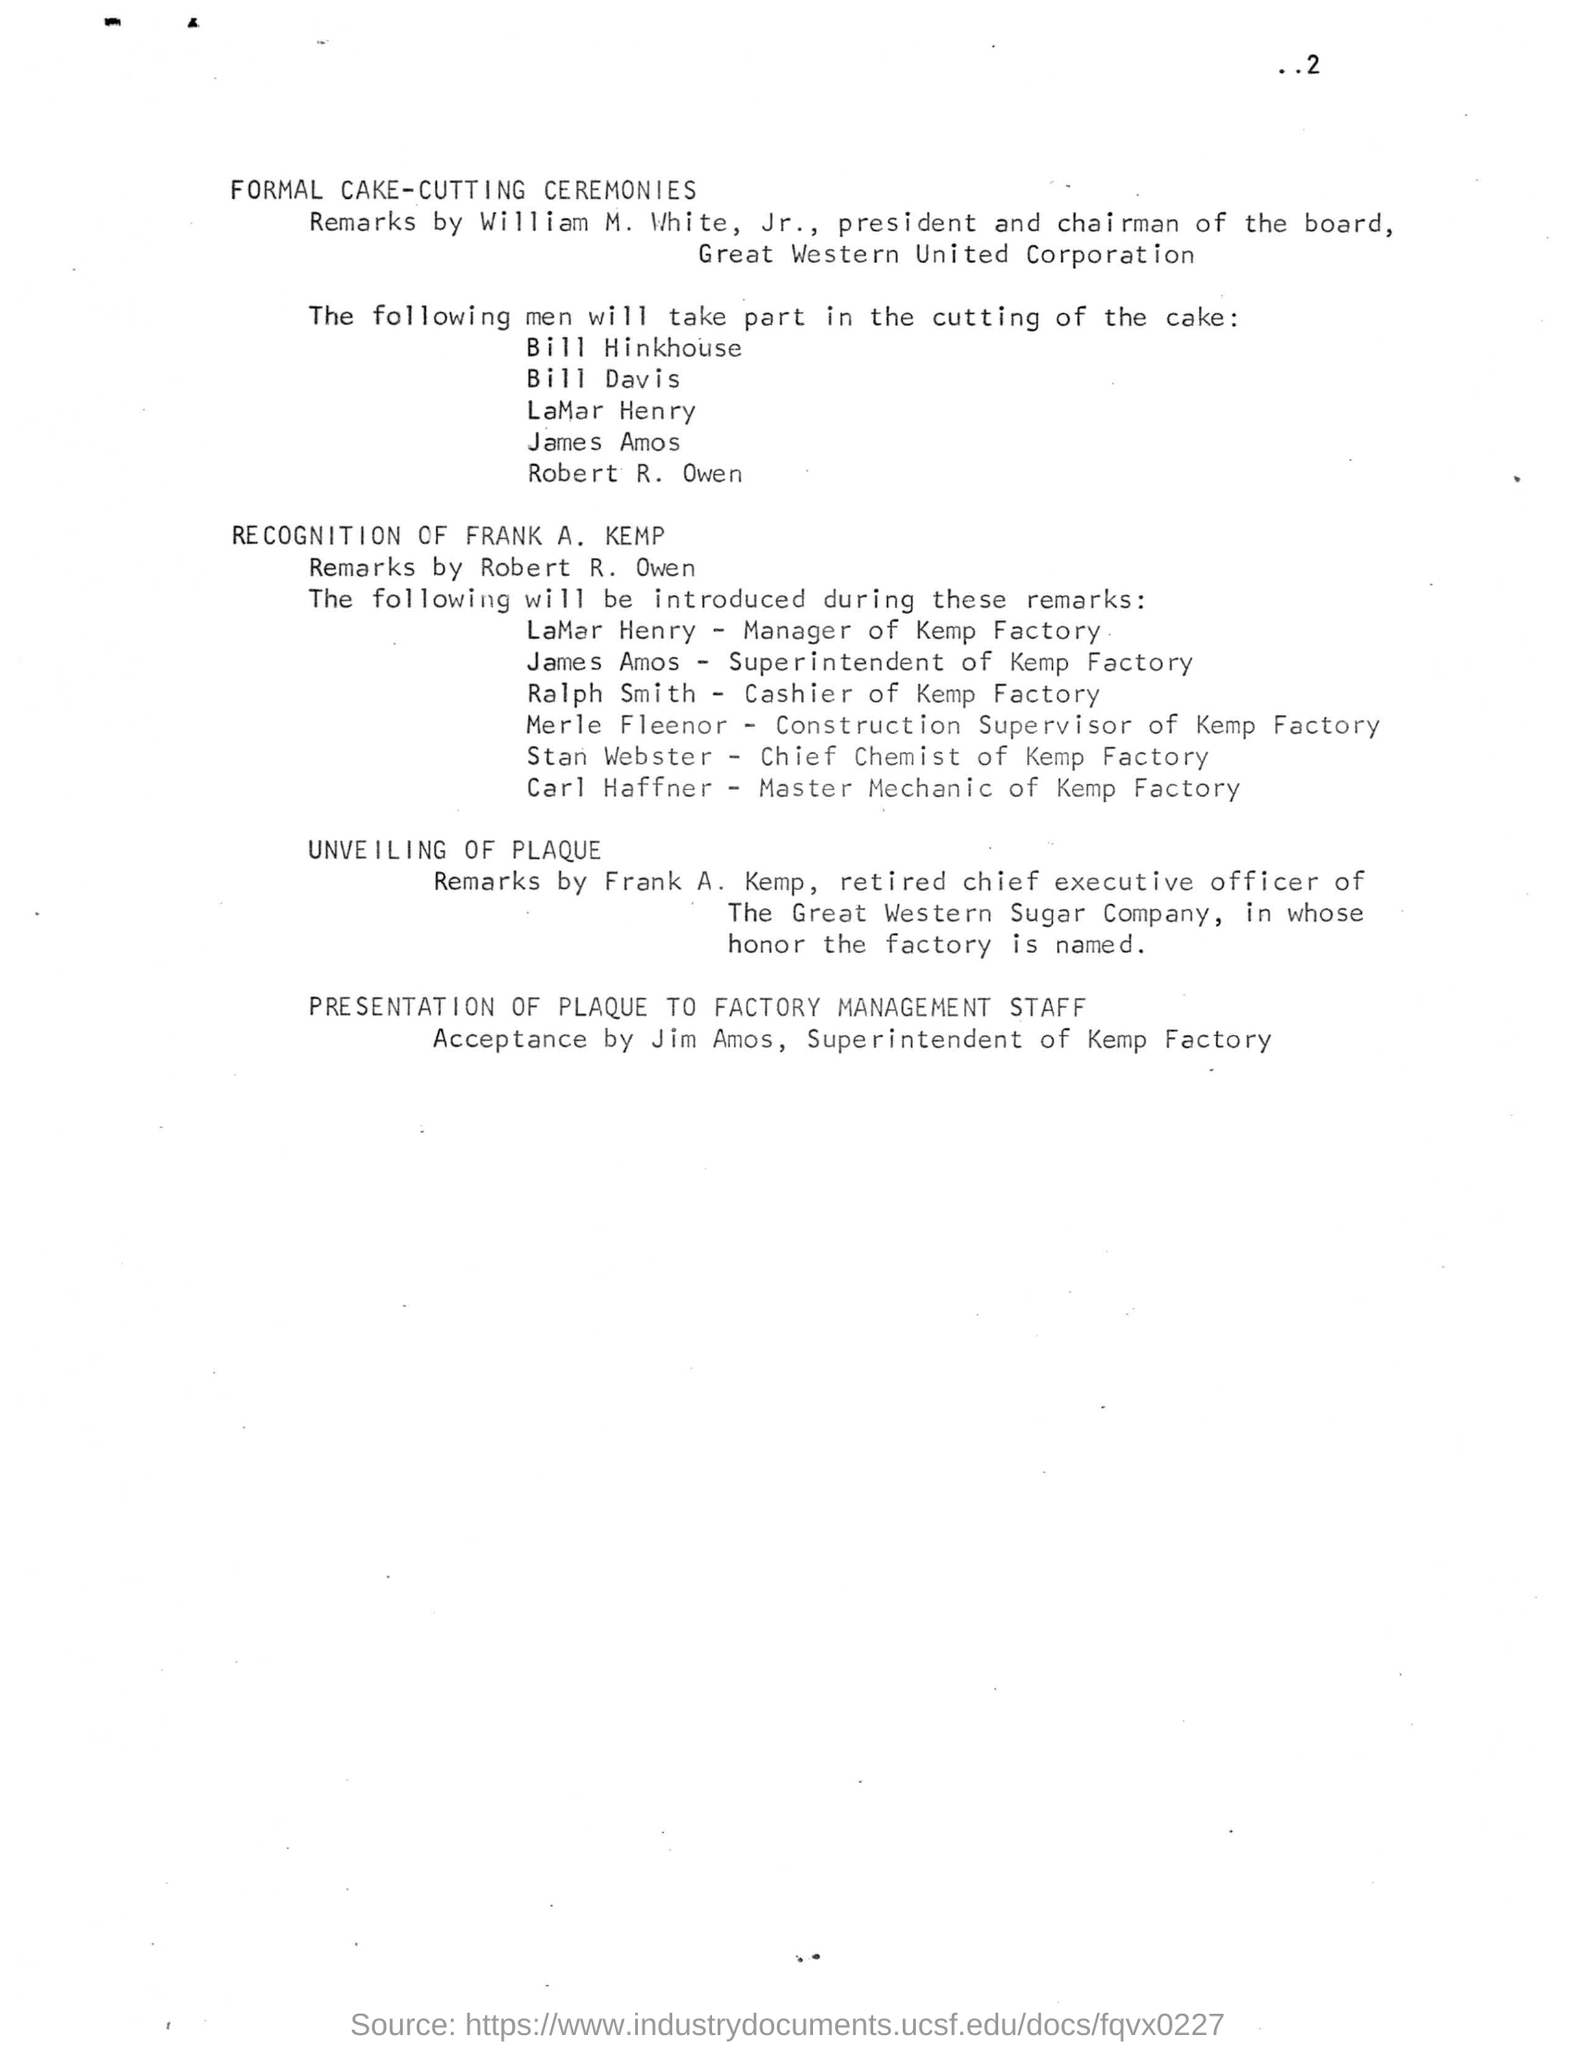Highlight a few significant elements in this photo. LaMar Henry is the manager of Kemp Factory. The honor of the factory's namesake, FRANK A. KEMP, is in question. William M. White, Jr. was the president and chairman of the board of Great Western United Corporation. 